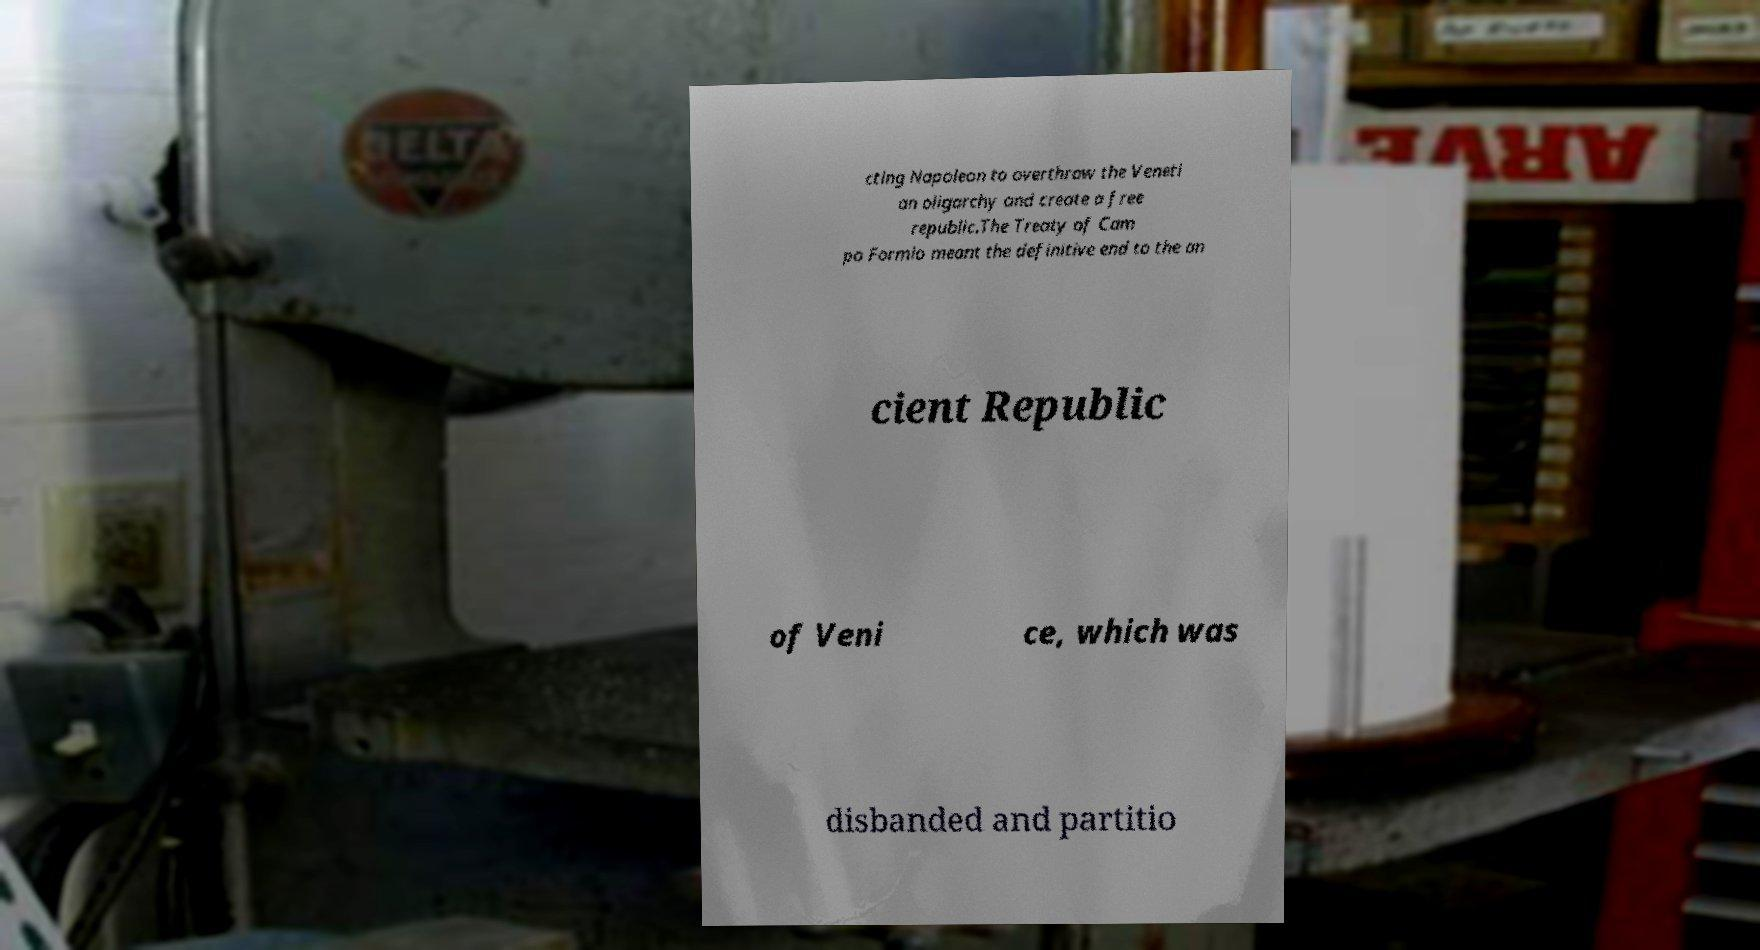Can you read and provide the text displayed in the image?This photo seems to have some interesting text. Can you extract and type it out for me? cting Napoleon to overthrow the Veneti an oligarchy and create a free republic.The Treaty of Cam po Formio meant the definitive end to the an cient Republic of Veni ce, which was disbanded and partitio 